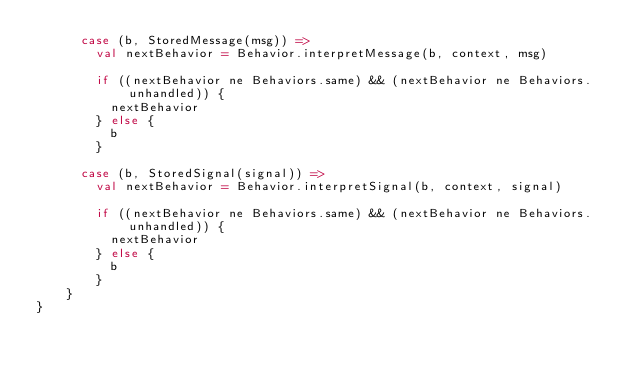Convert code to text. <code><loc_0><loc_0><loc_500><loc_500><_Scala_>      case (b, StoredMessage(msg)) =>
        val nextBehavior = Behavior.interpretMessage(b, context, msg)

        if ((nextBehavior ne Behaviors.same) && (nextBehavior ne Behaviors.unhandled)) {
          nextBehavior
        } else {
          b
        }

      case (b, StoredSignal(signal)) =>
        val nextBehavior = Behavior.interpretSignal(b, context, signal)

        if ((nextBehavior ne Behaviors.same) && (nextBehavior ne Behaviors.unhandled)) {
          nextBehavior
        } else {
          b
        }
    }
}
</code> 